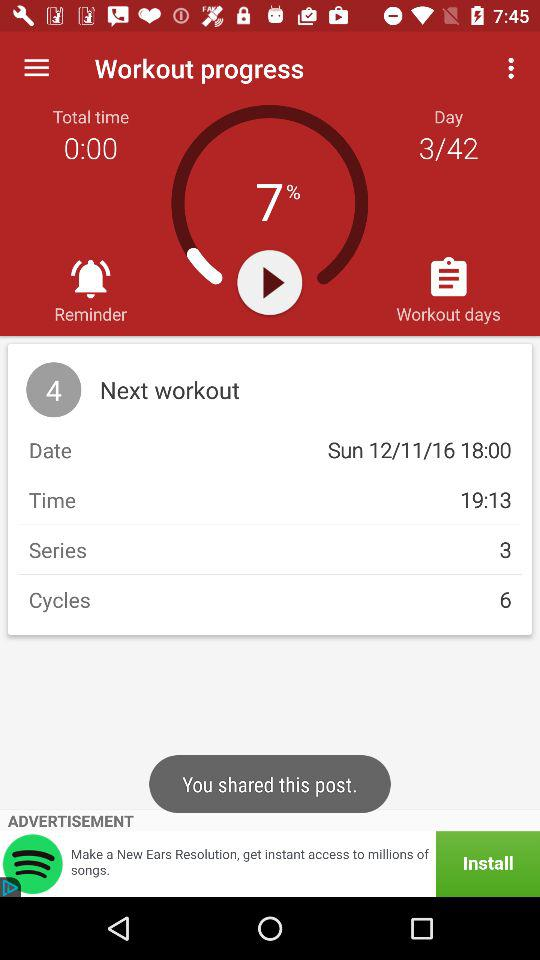How many more cycles are there than series?
Answer the question using a single word or phrase. 3 